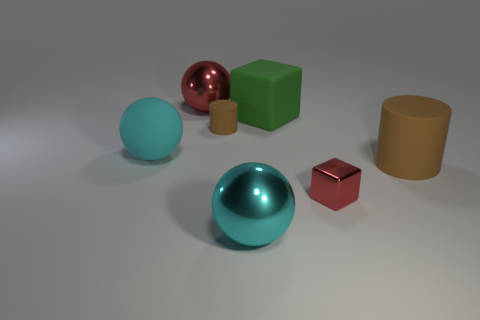What time of day does the lighting in this image suggest? The soft shadows and even lighting in the image do not strongly suggest a particular time of day; it appears to be artificially lit or rendered, simulating a neutral, non-specific time. 